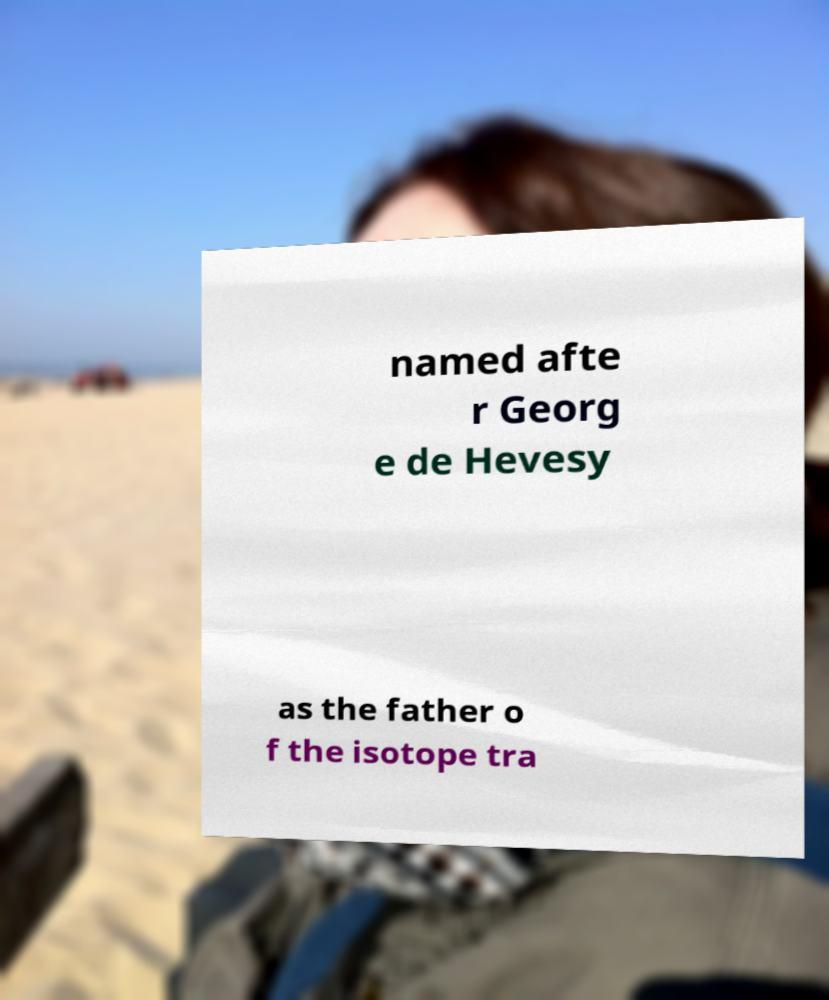Could you assist in decoding the text presented in this image and type it out clearly? named afte r Georg e de Hevesy as the father o f the isotope tra 